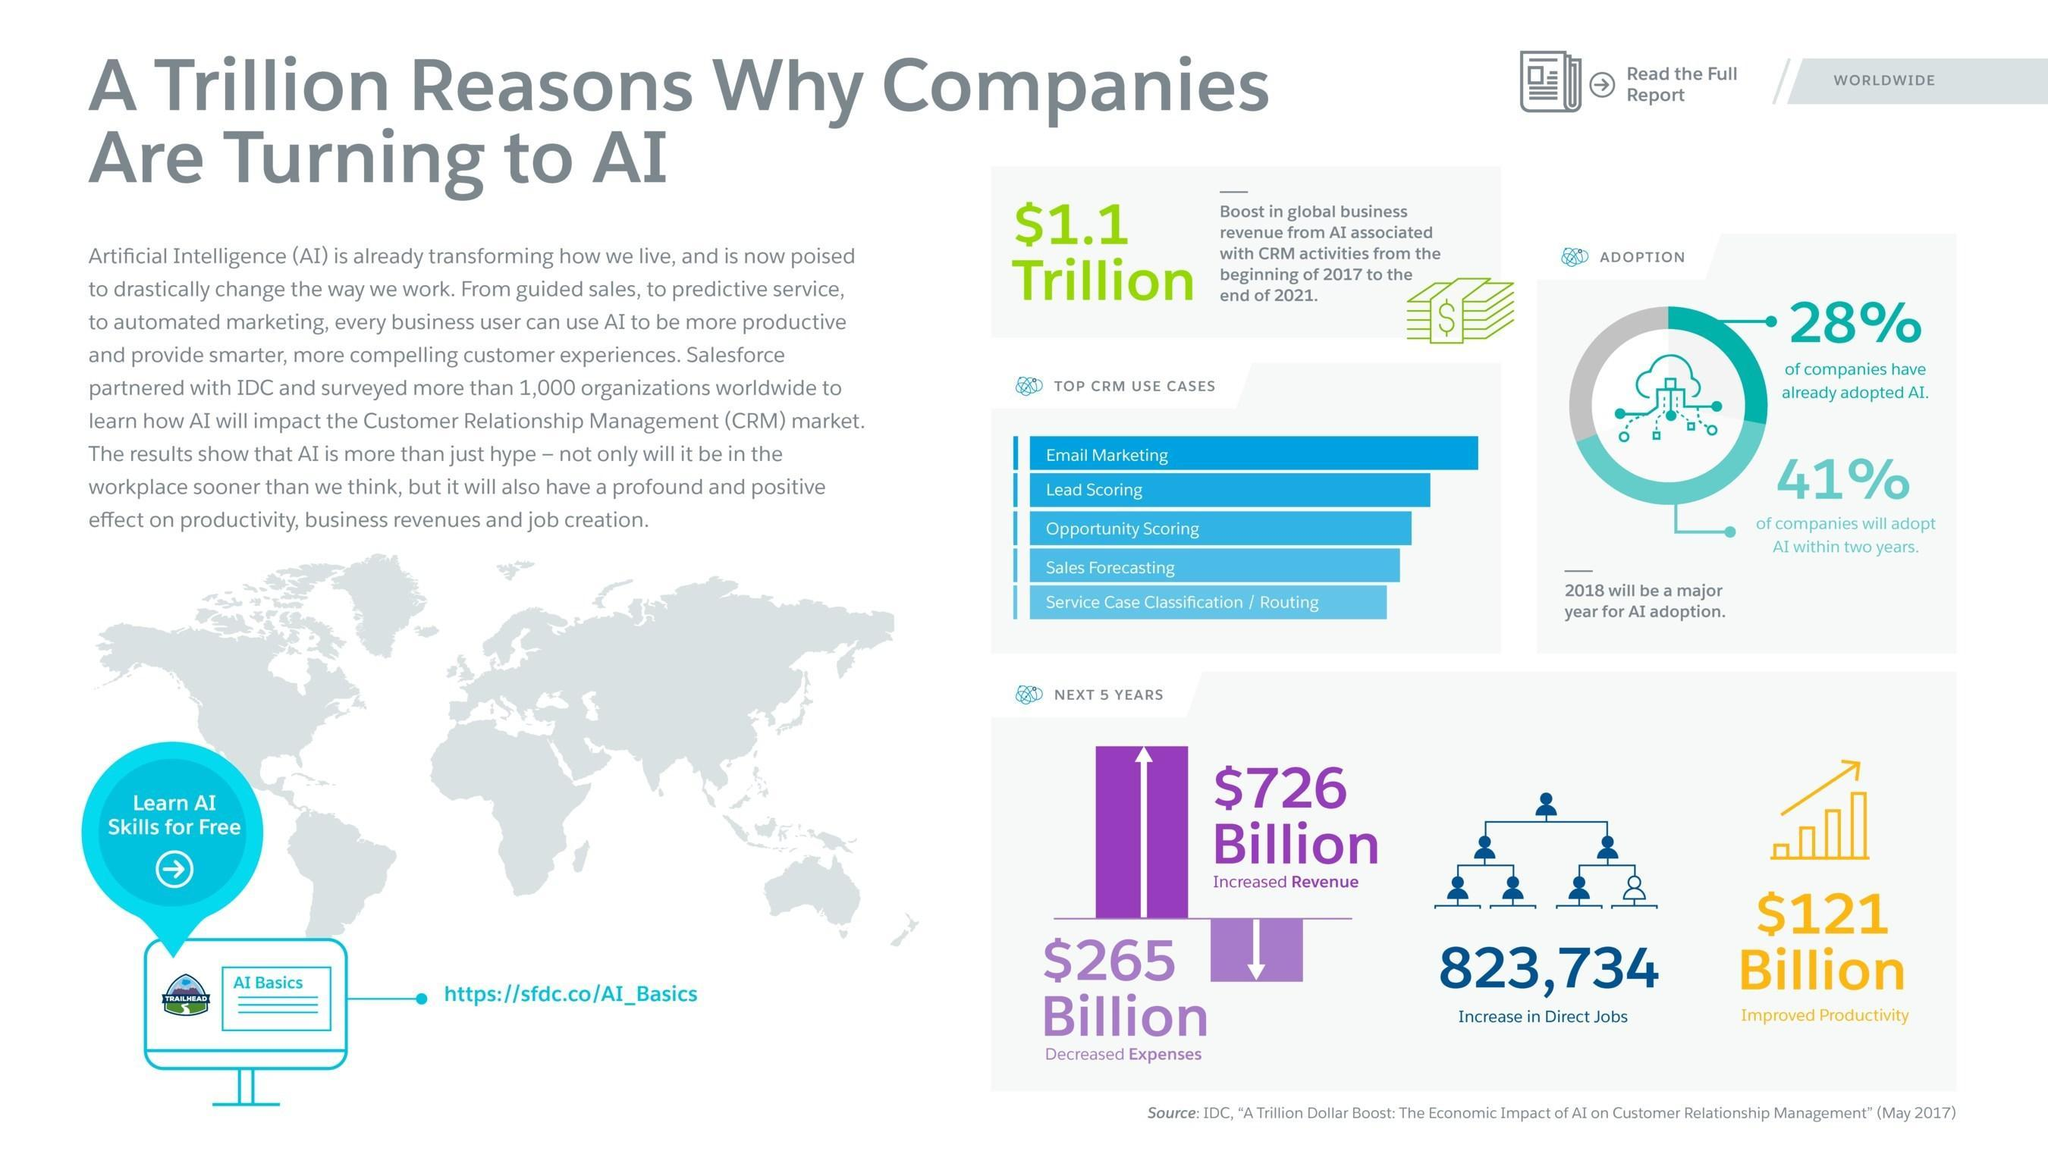What is the expected growth in the revenue by the adoption of AI in the next 5 years?
Answer the question with a short phrase. $726 Billion What percentage of the companies already adopted AI? 28% What will be the increase in the number of direct jobs in the market with the adoption of AI in the next five years? 823,734 What percentage of the companies will adopt AI within two years? 41% 